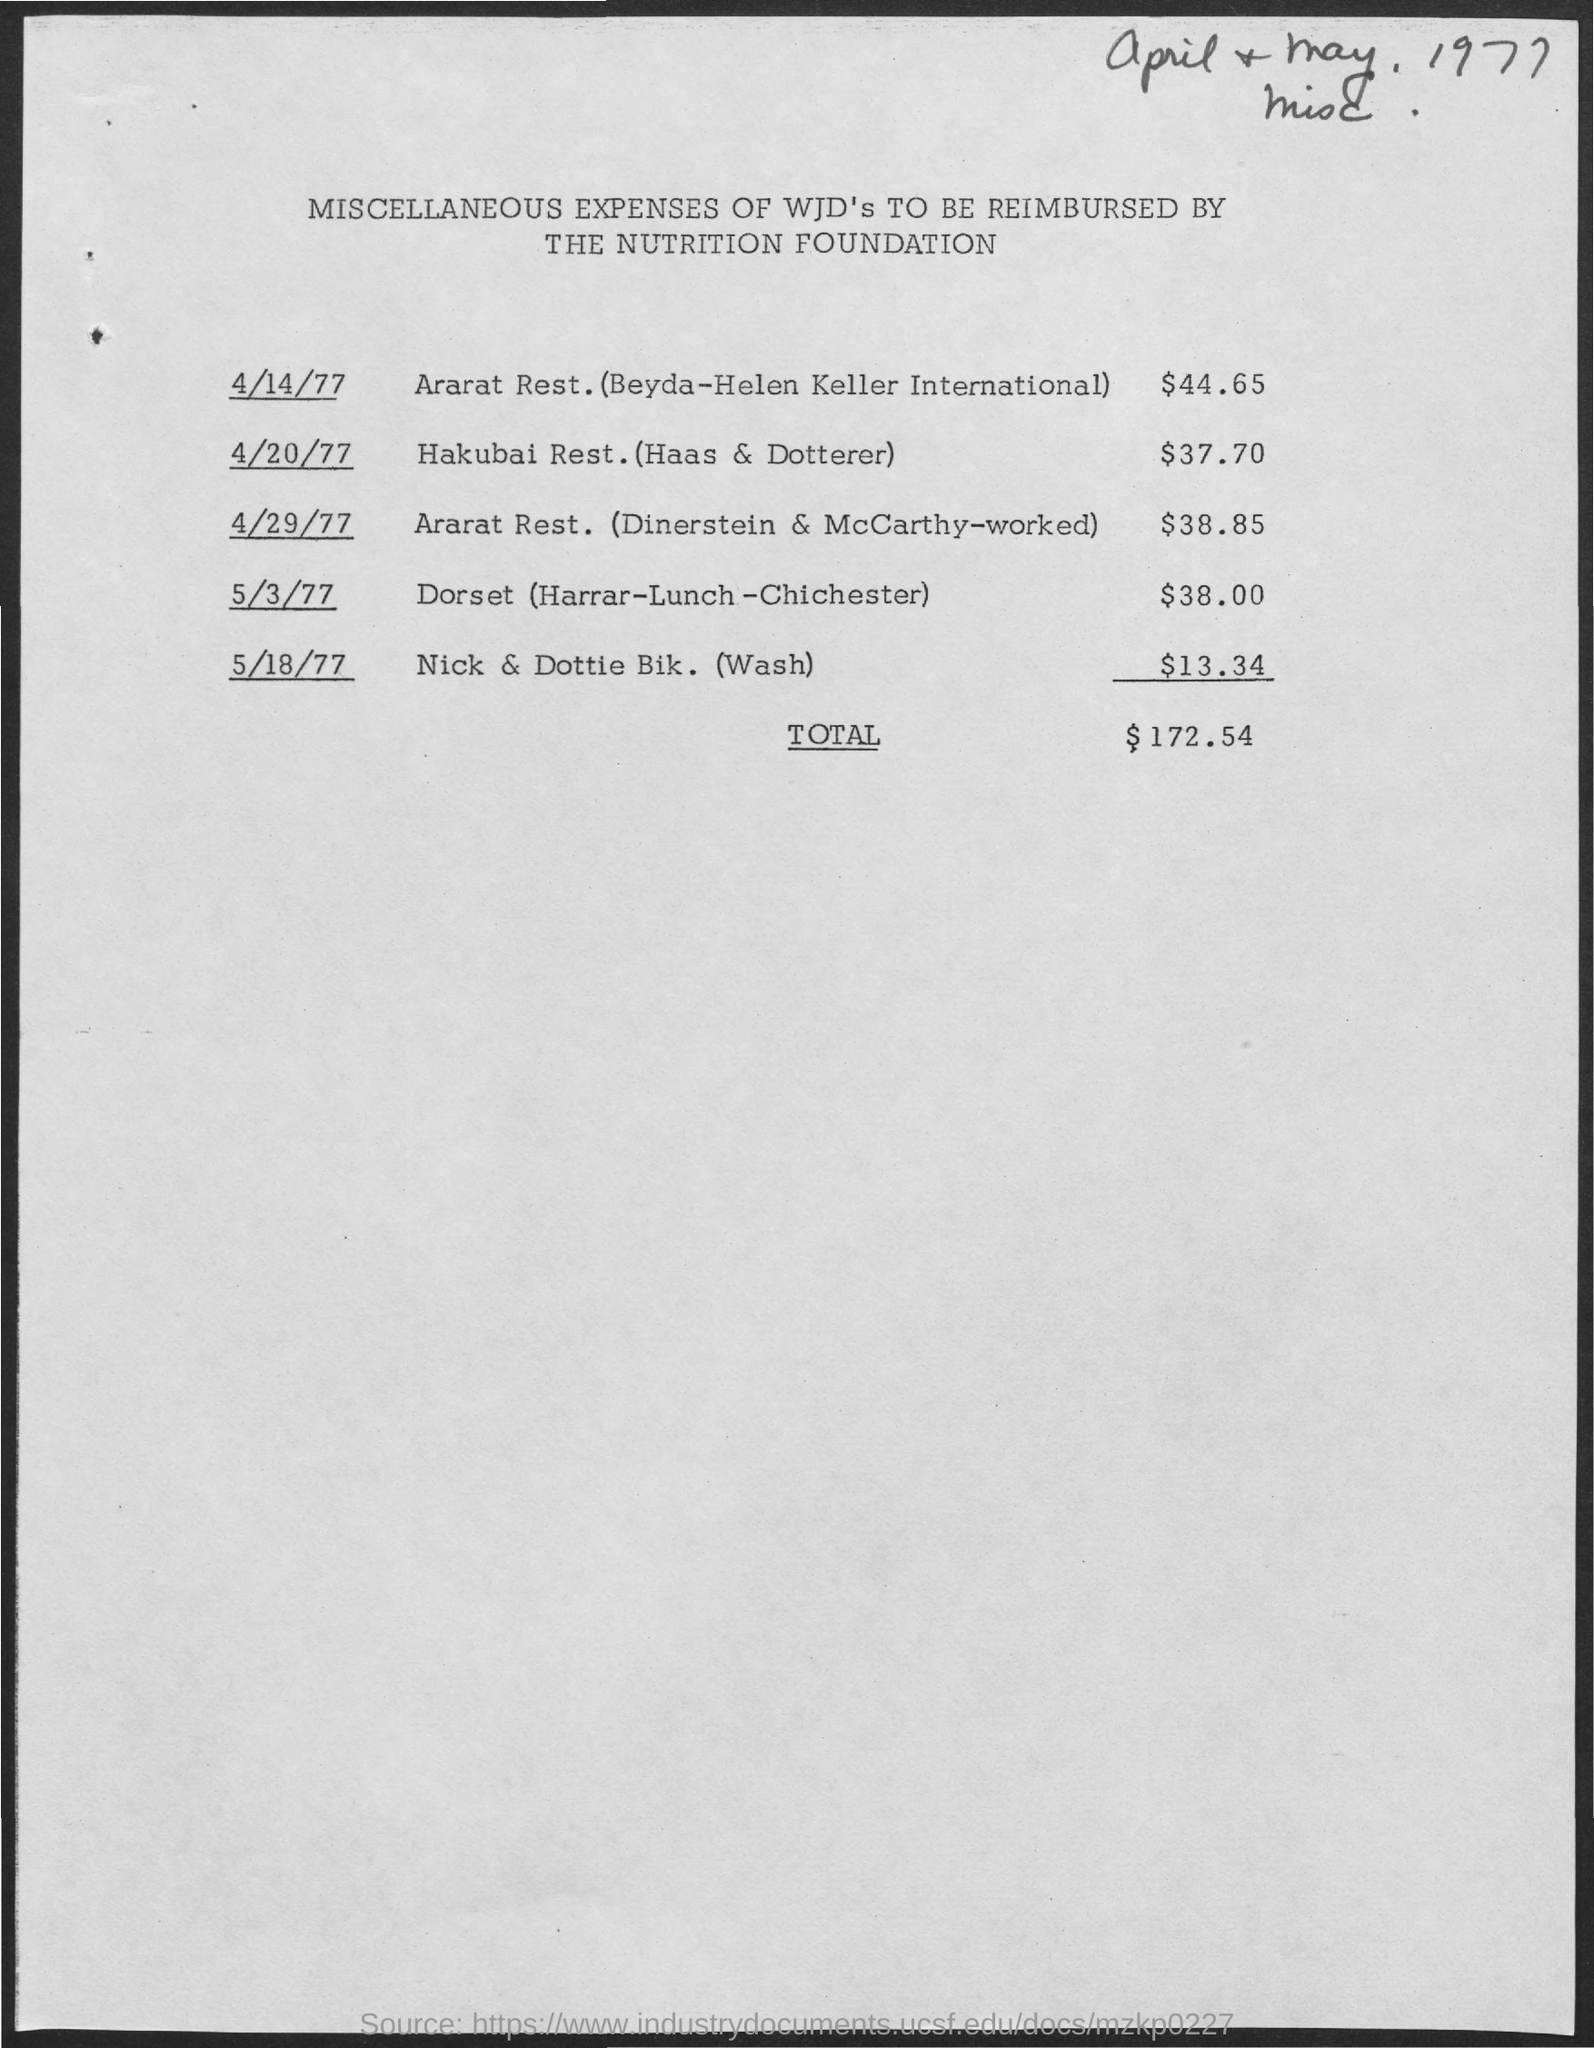What is the title of the given document?
Your answer should be compact. Miscellaneous Expenses of WJD's to be Reimbursed by The Nutrition Foundation. What is the total expenses of hakubai rest.(haas & dotterer)
Give a very brief answer. $37.70. What is the total expenses to be reimbursed?
Make the answer very short. $172.54. 